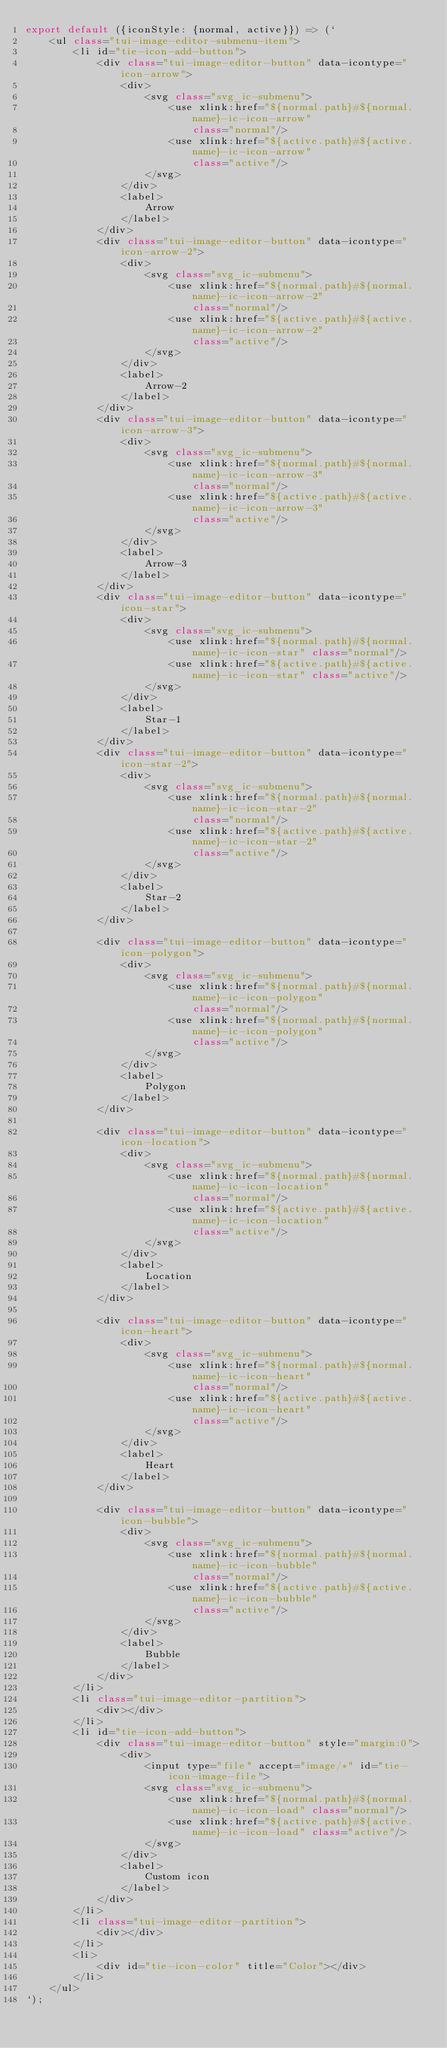<code> <loc_0><loc_0><loc_500><loc_500><_JavaScript_>export default ({iconStyle: {normal, active}}) => (`
    <ul class="tui-image-editor-submenu-item">
        <li id="tie-icon-add-button">
            <div class="tui-image-editor-button" data-icontype="icon-arrow">
                <div>
                    <svg class="svg_ic-submenu">
                        <use xlink:href="${normal.path}#${normal.name}-ic-icon-arrow"
                            class="normal"/>
                        <use xlink:href="${active.path}#${active.name}-ic-icon-arrow"
                            class="active"/>
                    </svg>
                </div>
                <label>
                    Arrow
                </label>
            </div>
            <div class="tui-image-editor-button" data-icontype="icon-arrow-2">
                <div>
                    <svg class="svg_ic-submenu">
                        <use xlink:href="${normal.path}#${normal.name}-ic-icon-arrow-2"
                            class="normal"/>
                        <use xlink:href="${active.path}#${active.name}-ic-icon-arrow-2"
                            class="active"/>
                    </svg>
                </div>
                <label>
                    Arrow-2
                </label>
            </div>
            <div class="tui-image-editor-button" data-icontype="icon-arrow-3">
                <div>
                    <svg class="svg_ic-submenu">
                        <use xlink:href="${normal.path}#${normal.name}-ic-icon-arrow-3"
                            class="normal"/>
                        <use xlink:href="${active.path}#${active.name}-ic-icon-arrow-3"
                            class="active"/>
                    </svg>
                </div>
                <label>
                    Arrow-3
                </label>
            </div>
            <div class="tui-image-editor-button" data-icontype="icon-star">
                <div>
                    <svg class="svg_ic-submenu">
                        <use xlink:href="${normal.path}#${normal.name}-ic-icon-star" class="normal"/>
                        <use xlink:href="${active.path}#${active.name}-ic-icon-star" class="active"/>
                    </svg>
                </div>
                <label>
                    Star-1
                </label>
            </div>
            <div class="tui-image-editor-button" data-icontype="icon-star-2">
                <div>
                    <svg class="svg_ic-submenu">
                        <use xlink:href="${normal.path}#${normal.name}-ic-icon-star-2"
                            class="normal"/>
                        <use xlink:href="${active.path}#${active.name}-ic-icon-star-2"
                            class="active"/>
                    </svg>
                </div>
                <label>
                    Star-2
                </label>
            </div>

            <div class="tui-image-editor-button" data-icontype="icon-polygon">
                <div>
                    <svg class="svg_ic-submenu">
                        <use xlink:href="${normal.path}#${normal.name}-ic-icon-polygon"
                            class="normal"/>
                        <use xlink:href="${normal.path}#${normal.name}-ic-icon-polygon"
                            class="active"/>
                    </svg>
                </div>
                <label>
                    Polygon
                </label>
            </div>

            <div class="tui-image-editor-button" data-icontype="icon-location">
                <div>
                    <svg class="svg_ic-submenu">
                        <use xlink:href="${normal.path}#${normal.name}-ic-icon-location"
                            class="normal"/>
                        <use xlink:href="${active.path}#${active.name}-ic-icon-location"
                            class="active"/>
                    </svg>
                </div>
                <label>
                    Location
                </label>
            </div>

            <div class="tui-image-editor-button" data-icontype="icon-heart">
                <div>
                    <svg class="svg_ic-submenu">
                        <use xlink:href="${normal.path}#${normal.name}-ic-icon-heart"
                            class="normal"/>
                        <use xlink:href="${active.path}#${active.name}-ic-icon-heart"
                            class="active"/>
                    </svg>
                </div>
                <label>
                    Heart
                </label>
            </div>

            <div class="tui-image-editor-button" data-icontype="icon-bubble">
                <div>
                    <svg class="svg_ic-submenu">
                        <use xlink:href="${normal.path}#${normal.name}-ic-icon-bubble"
                            class="normal"/>
                        <use xlink:href="${active.path}#${active.name}-ic-icon-bubble"
                            class="active"/>
                    </svg>
                </div>
                <label>
                    Bubble
                </label>
            </div>
        </li>
        <li class="tui-image-editor-partition">
            <div></div>
        </li>
        <li id="tie-icon-add-button">
            <div class="tui-image-editor-button" style="margin:0">
                <div>
                    <input type="file" accept="image/*" id="tie-icon-image-file">
                    <svg class="svg_ic-submenu">
                        <use xlink:href="${normal.path}#${normal.name}-ic-icon-load" class="normal"/>
                        <use xlink:href="${active.path}#${active.name}-ic-icon-load" class="active"/>
                    </svg>
                </div>
                <label>
                    Custom icon
                </label>
            </div>
        </li>
        <li class="tui-image-editor-partition">
            <div></div>
        </li>
        <li>
            <div id="tie-icon-color" title="Color"></div>
        </li>
    </ul>
`);
</code> 